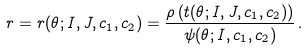<formula> <loc_0><loc_0><loc_500><loc_500>r = r ( \theta ; I , J , c _ { 1 } , c _ { 2 } ) = \frac { \rho \left ( t ( \theta ; I , J , c _ { 1 } , c _ { 2 } ) \right ) } { \psi ( \theta ; I , c _ { 1 } , c _ { 2 } ) } \, .</formula> 